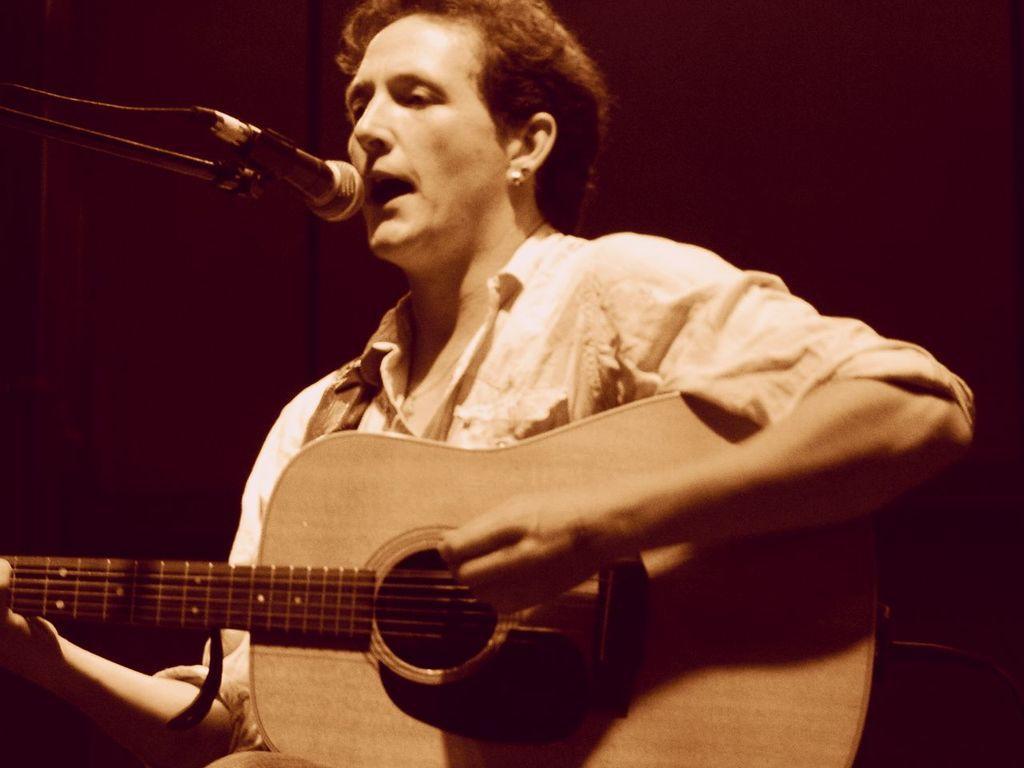How would you summarize this image in a sentence or two? In this image I can see a person playing the guitar and it seems like singing a song. In front of this person there is a mike stand. 